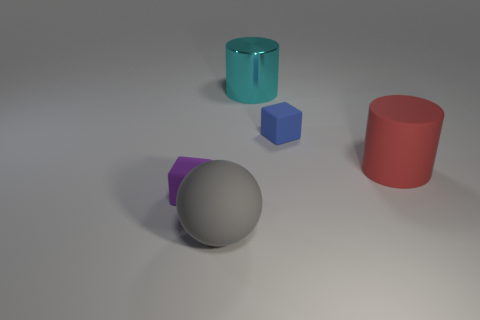There is a cyan thing that is the same size as the red rubber cylinder; what is it made of?
Your answer should be compact. Metal. Is there a small blue thing that has the same material as the cyan object?
Make the answer very short. No. Is the number of small purple matte things that are on the right side of the large gray rubber object less than the number of purple metallic balls?
Offer a terse response. No. What is the material of the big object that is in front of the large thing on the right side of the blue matte thing?
Make the answer very short. Rubber. What is the shape of the thing that is both on the right side of the cyan shiny cylinder and behind the large red matte object?
Your answer should be compact. Cube. What number of other things are there of the same color as the big metallic cylinder?
Your answer should be very brief. 0. What number of things are cylinders to the left of the blue thing or blue objects?
Offer a very short reply. 2. What is the size of the object left of the big matte object in front of the small purple object?
Offer a very short reply. Small. How many things are either tiny blue metallic things or cylinders that are behind the red matte cylinder?
Provide a succinct answer. 1. Is the shape of the small rubber object that is left of the tiny blue matte object the same as  the blue thing?
Ensure brevity in your answer.  Yes. 